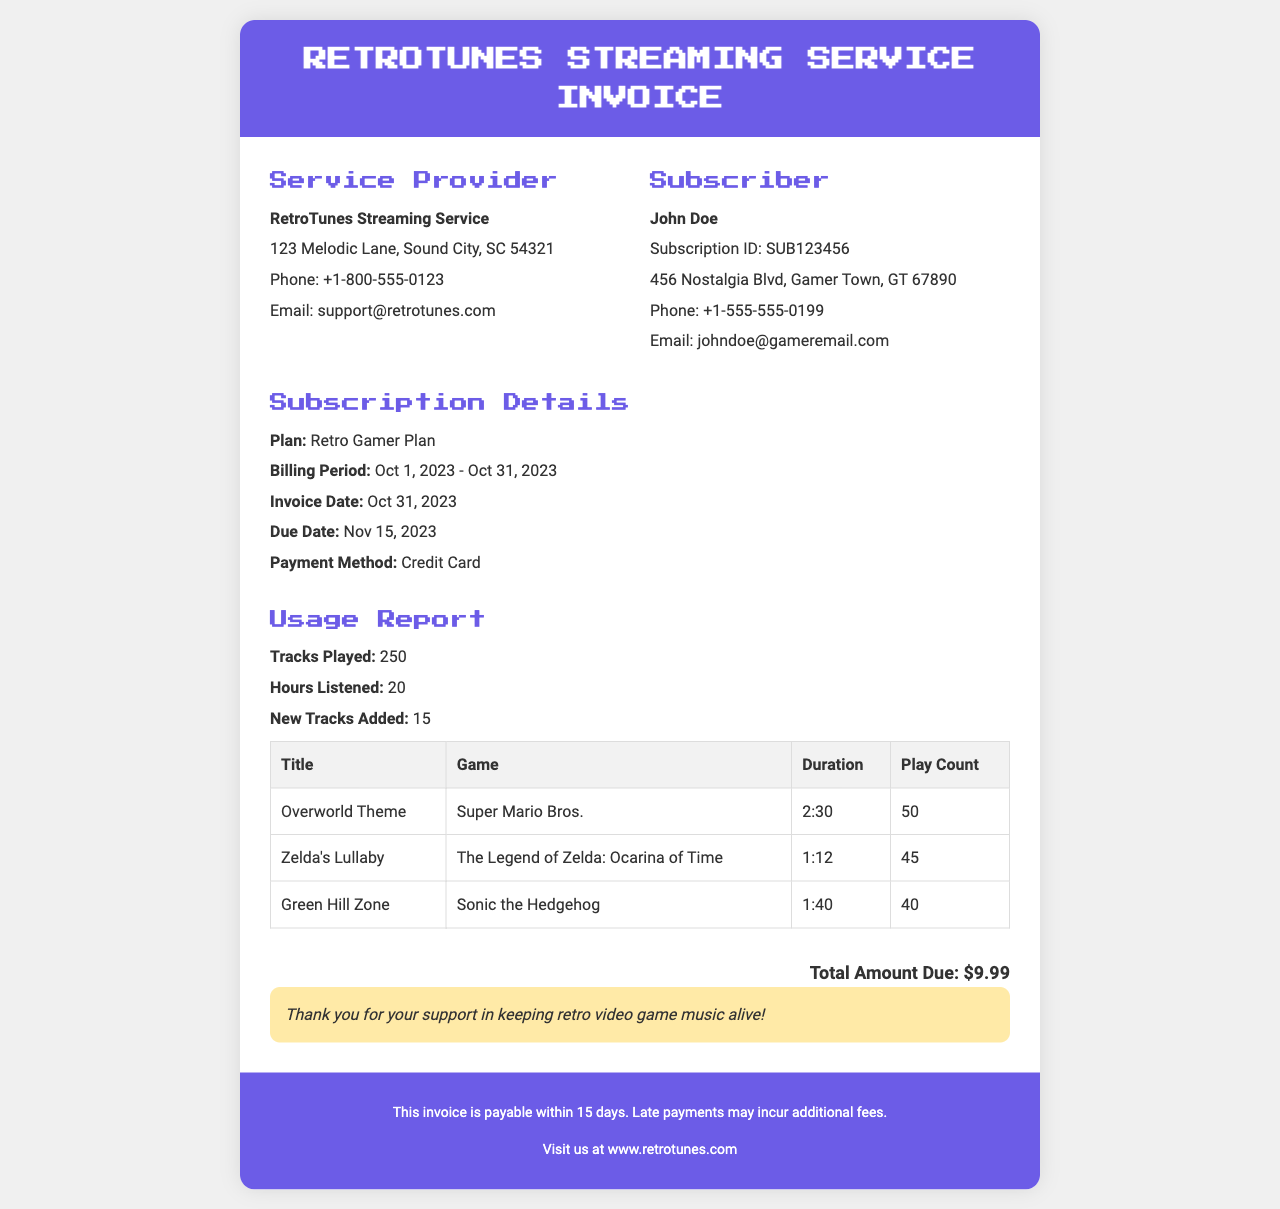what is the total amount due? The total amount due is clearly stated in the invoice as the final total that needs to be paid by the subscriber.
Answer: $9.99 who is the subscriber? The subscriber's information is provided in the details section, including their name and contact information.
Answer: John Doe what is the subscription plan? The plan type is specified in the subscription details section of the invoice.
Answer: Retro Gamer Plan how many tracks were played? The usage report section indicates the total number of tracks played during the billing period.
Answer: 250 what is the billing period? The billing period is specified in the subscription details, showing the duration of the subscription for that invoice.
Answer: Oct 1, 2023 - Oct 31, 2023 when is the due date? The due date for the invoice payment is listed among the subscription details.
Answer: Nov 15, 2023 how many hours listened? The usage report section outlines the total listening time for the subscriber.
Answer: 20 what is the email address for support? The email contact for support is listed in the service provider's information.
Answer: support@retrotunes.com how many new tracks were added? The usage report details the number of new tracks that have been added during the billing period.
Answer: 15 